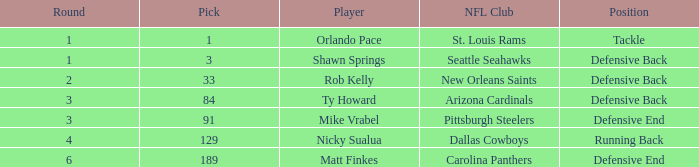What lowest round has orlando pace as the player? 1.0. 